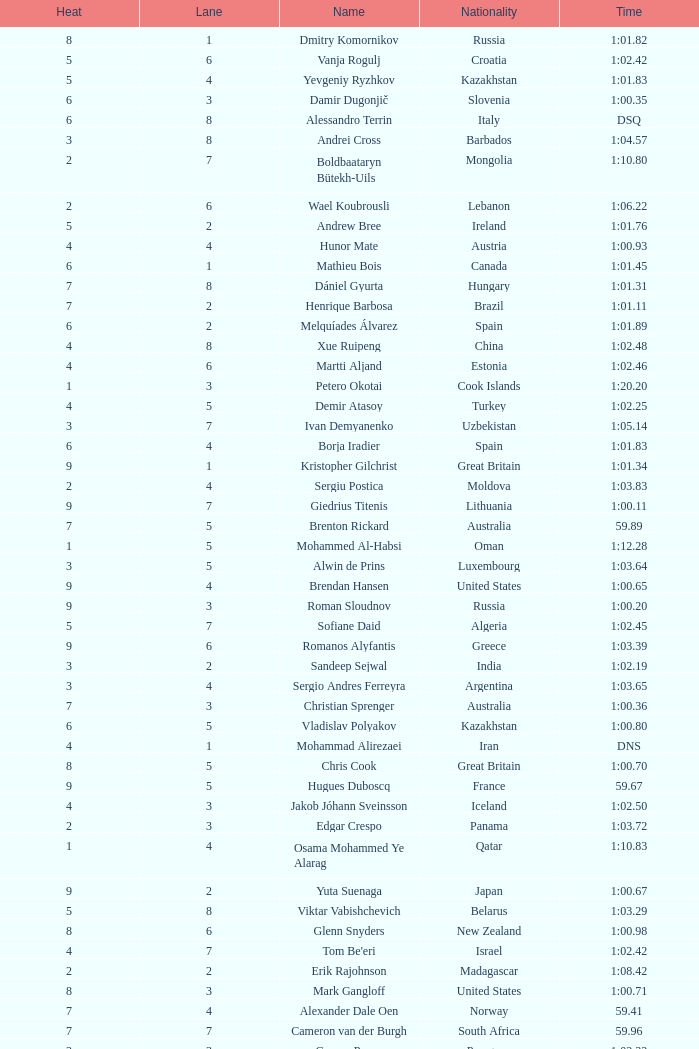What is the smallest lane number of Xue Ruipeng? 8.0. 